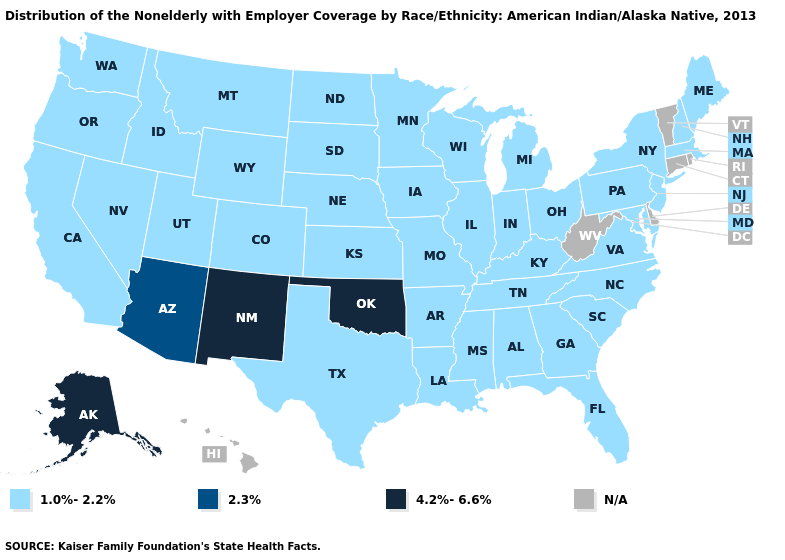What is the value of Montana?
Write a very short answer. 1.0%-2.2%. Which states have the lowest value in the USA?
Concise answer only. Alabama, Arkansas, California, Colorado, Florida, Georgia, Idaho, Illinois, Indiana, Iowa, Kansas, Kentucky, Louisiana, Maine, Maryland, Massachusetts, Michigan, Minnesota, Mississippi, Missouri, Montana, Nebraska, Nevada, New Hampshire, New Jersey, New York, North Carolina, North Dakota, Ohio, Oregon, Pennsylvania, South Carolina, South Dakota, Tennessee, Texas, Utah, Virginia, Washington, Wisconsin, Wyoming. What is the highest value in states that border California?
Keep it brief. 2.3%. Does the map have missing data?
Quick response, please. Yes. What is the lowest value in the South?
Write a very short answer. 1.0%-2.2%. What is the value of Iowa?
Quick response, please. 1.0%-2.2%. What is the highest value in states that border Rhode Island?
Concise answer only. 1.0%-2.2%. What is the lowest value in states that border Delaware?
Short answer required. 1.0%-2.2%. Which states have the lowest value in the MidWest?
Answer briefly. Illinois, Indiana, Iowa, Kansas, Michigan, Minnesota, Missouri, Nebraska, North Dakota, Ohio, South Dakota, Wisconsin. Does the first symbol in the legend represent the smallest category?
Keep it brief. Yes. Which states have the lowest value in the USA?
Be succinct. Alabama, Arkansas, California, Colorado, Florida, Georgia, Idaho, Illinois, Indiana, Iowa, Kansas, Kentucky, Louisiana, Maine, Maryland, Massachusetts, Michigan, Minnesota, Mississippi, Missouri, Montana, Nebraska, Nevada, New Hampshire, New Jersey, New York, North Carolina, North Dakota, Ohio, Oregon, Pennsylvania, South Carolina, South Dakota, Tennessee, Texas, Utah, Virginia, Washington, Wisconsin, Wyoming. Does the first symbol in the legend represent the smallest category?
Give a very brief answer. Yes. Which states have the lowest value in the South?
Be succinct. Alabama, Arkansas, Florida, Georgia, Kentucky, Louisiana, Maryland, Mississippi, North Carolina, South Carolina, Tennessee, Texas, Virginia. What is the lowest value in the MidWest?
Keep it brief. 1.0%-2.2%. Name the states that have a value in the range 2.3%?
Keep it brief. Arizona. 